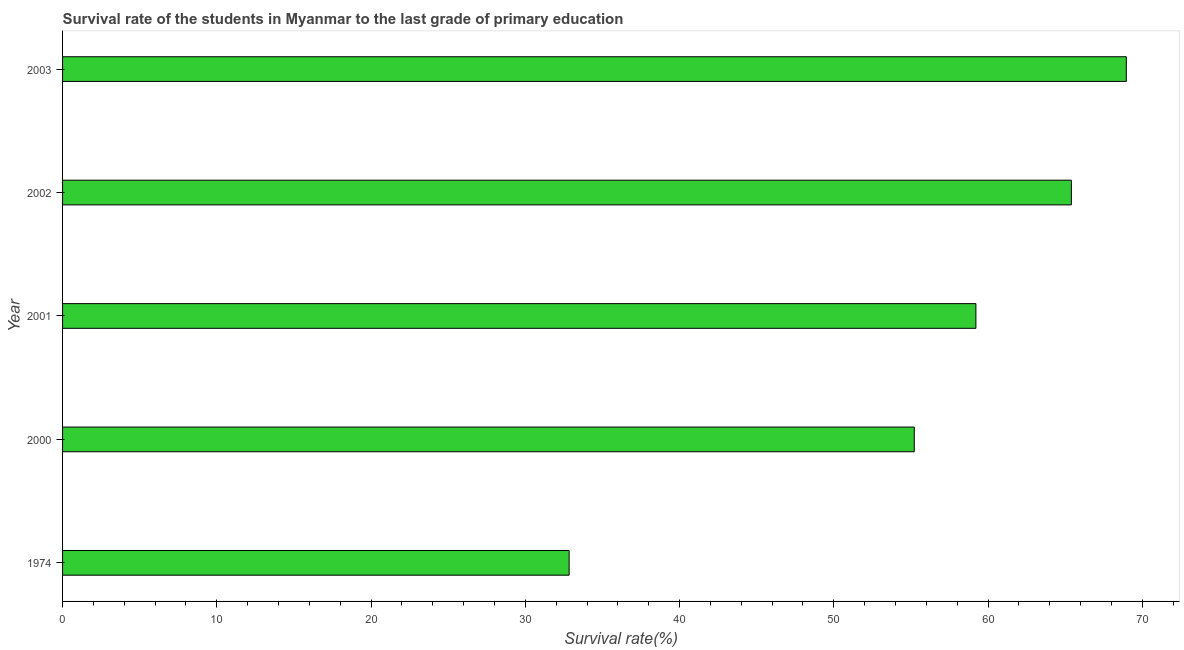Does the graph contain grids?
Ensure brevity in your answer.  No. What is the title of the graph?
Your answer should be very brief. Survival rate of the students in Myanmar to the last grade of primary education. What is the label or title of the X-axis?
Give a very brief answer. Survival rate(%). What is the label or title of the Y-axis?
Your answer should be compact. Year. What is the survival rate in primary education in 2000?
Make the answer very short. 55.22. Across all years, what is the maximum survival rate in primary education?
Your answer should be very brief. 68.96. Across all years, what is the minimum survival rate in primary education?
Provide a succinct answer. 32.84. In which year was the survival rate in primary education minimum?
Your answer should be very brief. 1974. What is the sum of the survival rate in primary education?
Provide a succinct answer. 281.64. What is the difference between the survival rate in primary education in 1974 and 2002?
Provide a short and direct response. -32.56. What is the average survival rate in primary education per year?
Give a very brief answer. 56.33. What is the median survival rate in primary education?
Your answer should be very brief. 59.21. In how many years, is the survival rate in primary education greater than 42 %?
Make the answer very short. 4. Do a majority of the years between 2002 and 2003 (inclusive) have survival rate in primary education greater than 6 %?
Ensure brevity in your answer.  Yes. What is the ratio of the survival rate in primary education in 2000 to that in 2001?
Offer a terse response. 0.93. Is the difference between the survival rate in primary education in 2000 and 2003 greater than the difference between any two years?
Provide a short and direct response. No. What is the difference between the highest and the second highest survival rate in primary education?
Offer a terse response. 3.56. Is the sum of the survival rate in primary education in 1974 and 2001 greater than the maximum survival rate in primary education across all years?
Your answer should be compact. Yes. What is the difference between the highest and the lowest survival rate in primary education?
Provide a short and direct response. 36.12. Are the values on the major ticks of X-axis written in scientific E-notation?
Offer a very short reply. No. What is the Survival rate(%) of 1974?
Your response must be concise. 32.84. What is the Survival rate(%) of 2000?
Your response must be concise. 55.22. What is the Survival rate(%) of 2001?
Your answer should be compact. 59.21. What is the Survival rate(%) of 2002?
Give a very brief answer. 65.4. What is the Survival rate(%) in 2003?
Offer a terse response. 68.96. What is the difference between the Survival rate(%) in 1974 and 2000?
Give a very brief answer. -22.38. What is the difference between the Survival rate(%) in 1974 and 2001?
Your answer should be compact. -26.37. What is the difference between the Survival rate(%) in 1974 and 2002?
Make the answer very short. -32.56. What is the difference between the Survival rate(%) in 1974 and 2003?
Your answer should be compact. -36.12. What is the difference between the Survival rate(%) in 2000 and 2001?
Give a very brief answer. -4. What is the difference between the Survival rate(%) in 2000 and 2002?
Give a very brief answer. -10.19. What is the difference between the Survival rate(%) in 2000 and 2003?
Ensure brevity in your answer.  -13.75. What is the difference between the Survival rate(%) in 2001 and 2002?
Give a very brief answer. -6.19. What is the difference between the Survival rate(%) in 2001 and 2003?
Offer a terse response. -9.75. What is the difference between the Survival rate(%) in 2002 and 2003?
Keep it short and to the point. -3.56. What is the ratio of the Survival rate(%) in 1974 to that in 2000?
Provide a succinct answer. 0.59. What is the ratio of the Survival rate(%) in 1974 to that in 2001?
Offer a very short reply. 0.56. What is the ratio of the Survival rate(%) in 1974 to that in 2002?
Provide a short and direct response. 0.5. What is the ratio of the Survival rate(%) in 1974 to that in 2003?
Offer a terse response. 0.48. What is the ratio of the Survival rate(%) in 2000 to that in 2001?
Make the answer very short. 0.93. What is the ratio of the Survival rate(%) in 2000 to that in 2002?
Give a very brief answer. 0.84. What is the ratio of the Survival rate(%) in 2000 to that in 2003?
Your answer should be very brief. 0.8. What is the ratio of the Survival rate(%) in 2001 to that in 2002?
Your answer should be very brief. 0.91. What is the ratio of the Survival rate(%) in 2001 to that in 2003?
Your answer should be compact. 0.86. What is the ratio of the Survival rate(%) in 2002 to that in 2003?
Your answer should be compact. 0.95. 